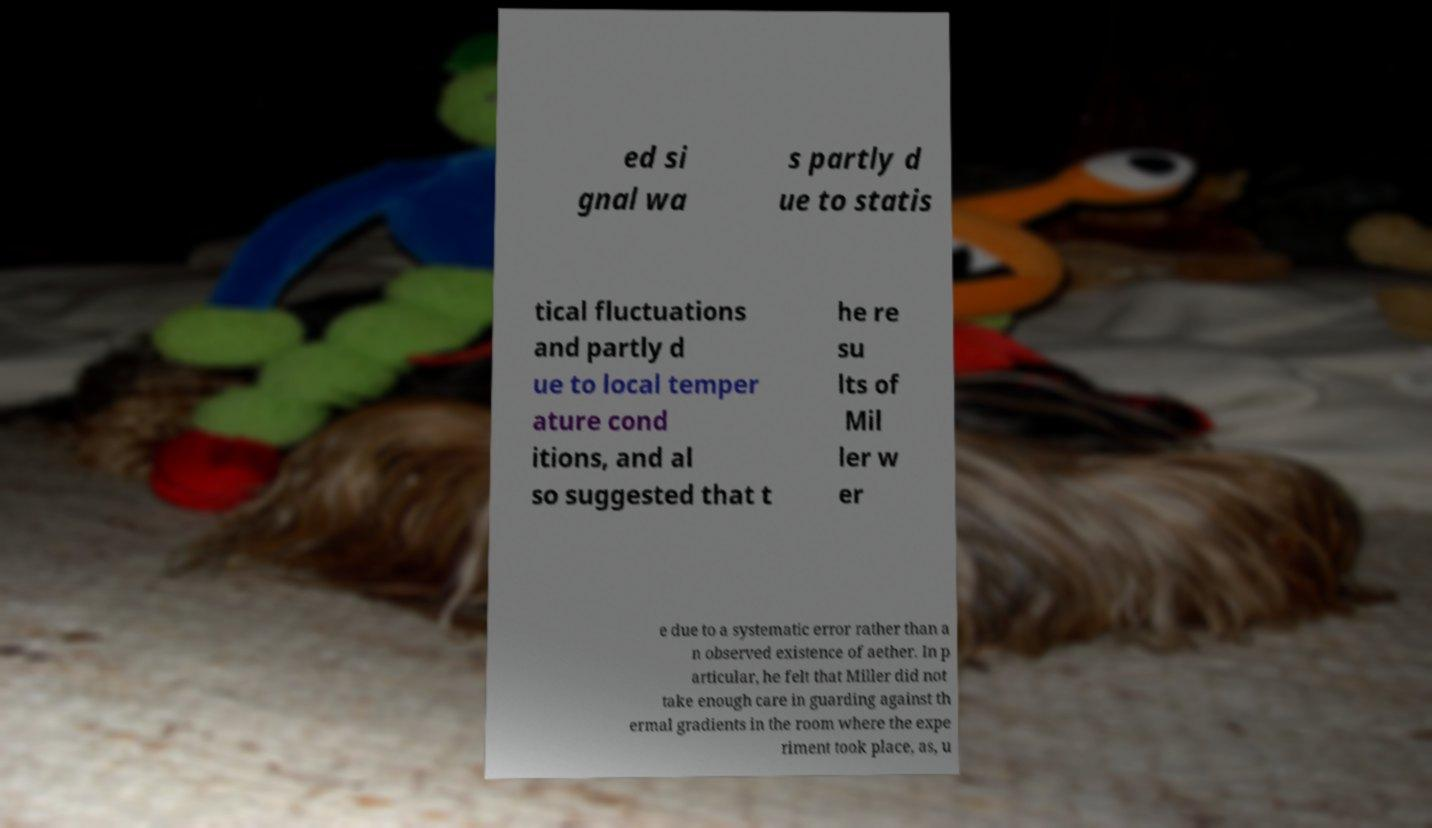For documentation purposes, I need the text within this image transcribed. Could you provide that? ed si gnal wa s partly d ue to statis tical fluctuations and partly d ue to local temper ature cond itions, and al so suggested that t he re su lts of Mil ler w er e due to a systematic error rather than a n observed existence of aether. In p articular, he felt that Miller did not take enough care in guarding against th ermal gradients in the room where the expe riment took place, as, u 